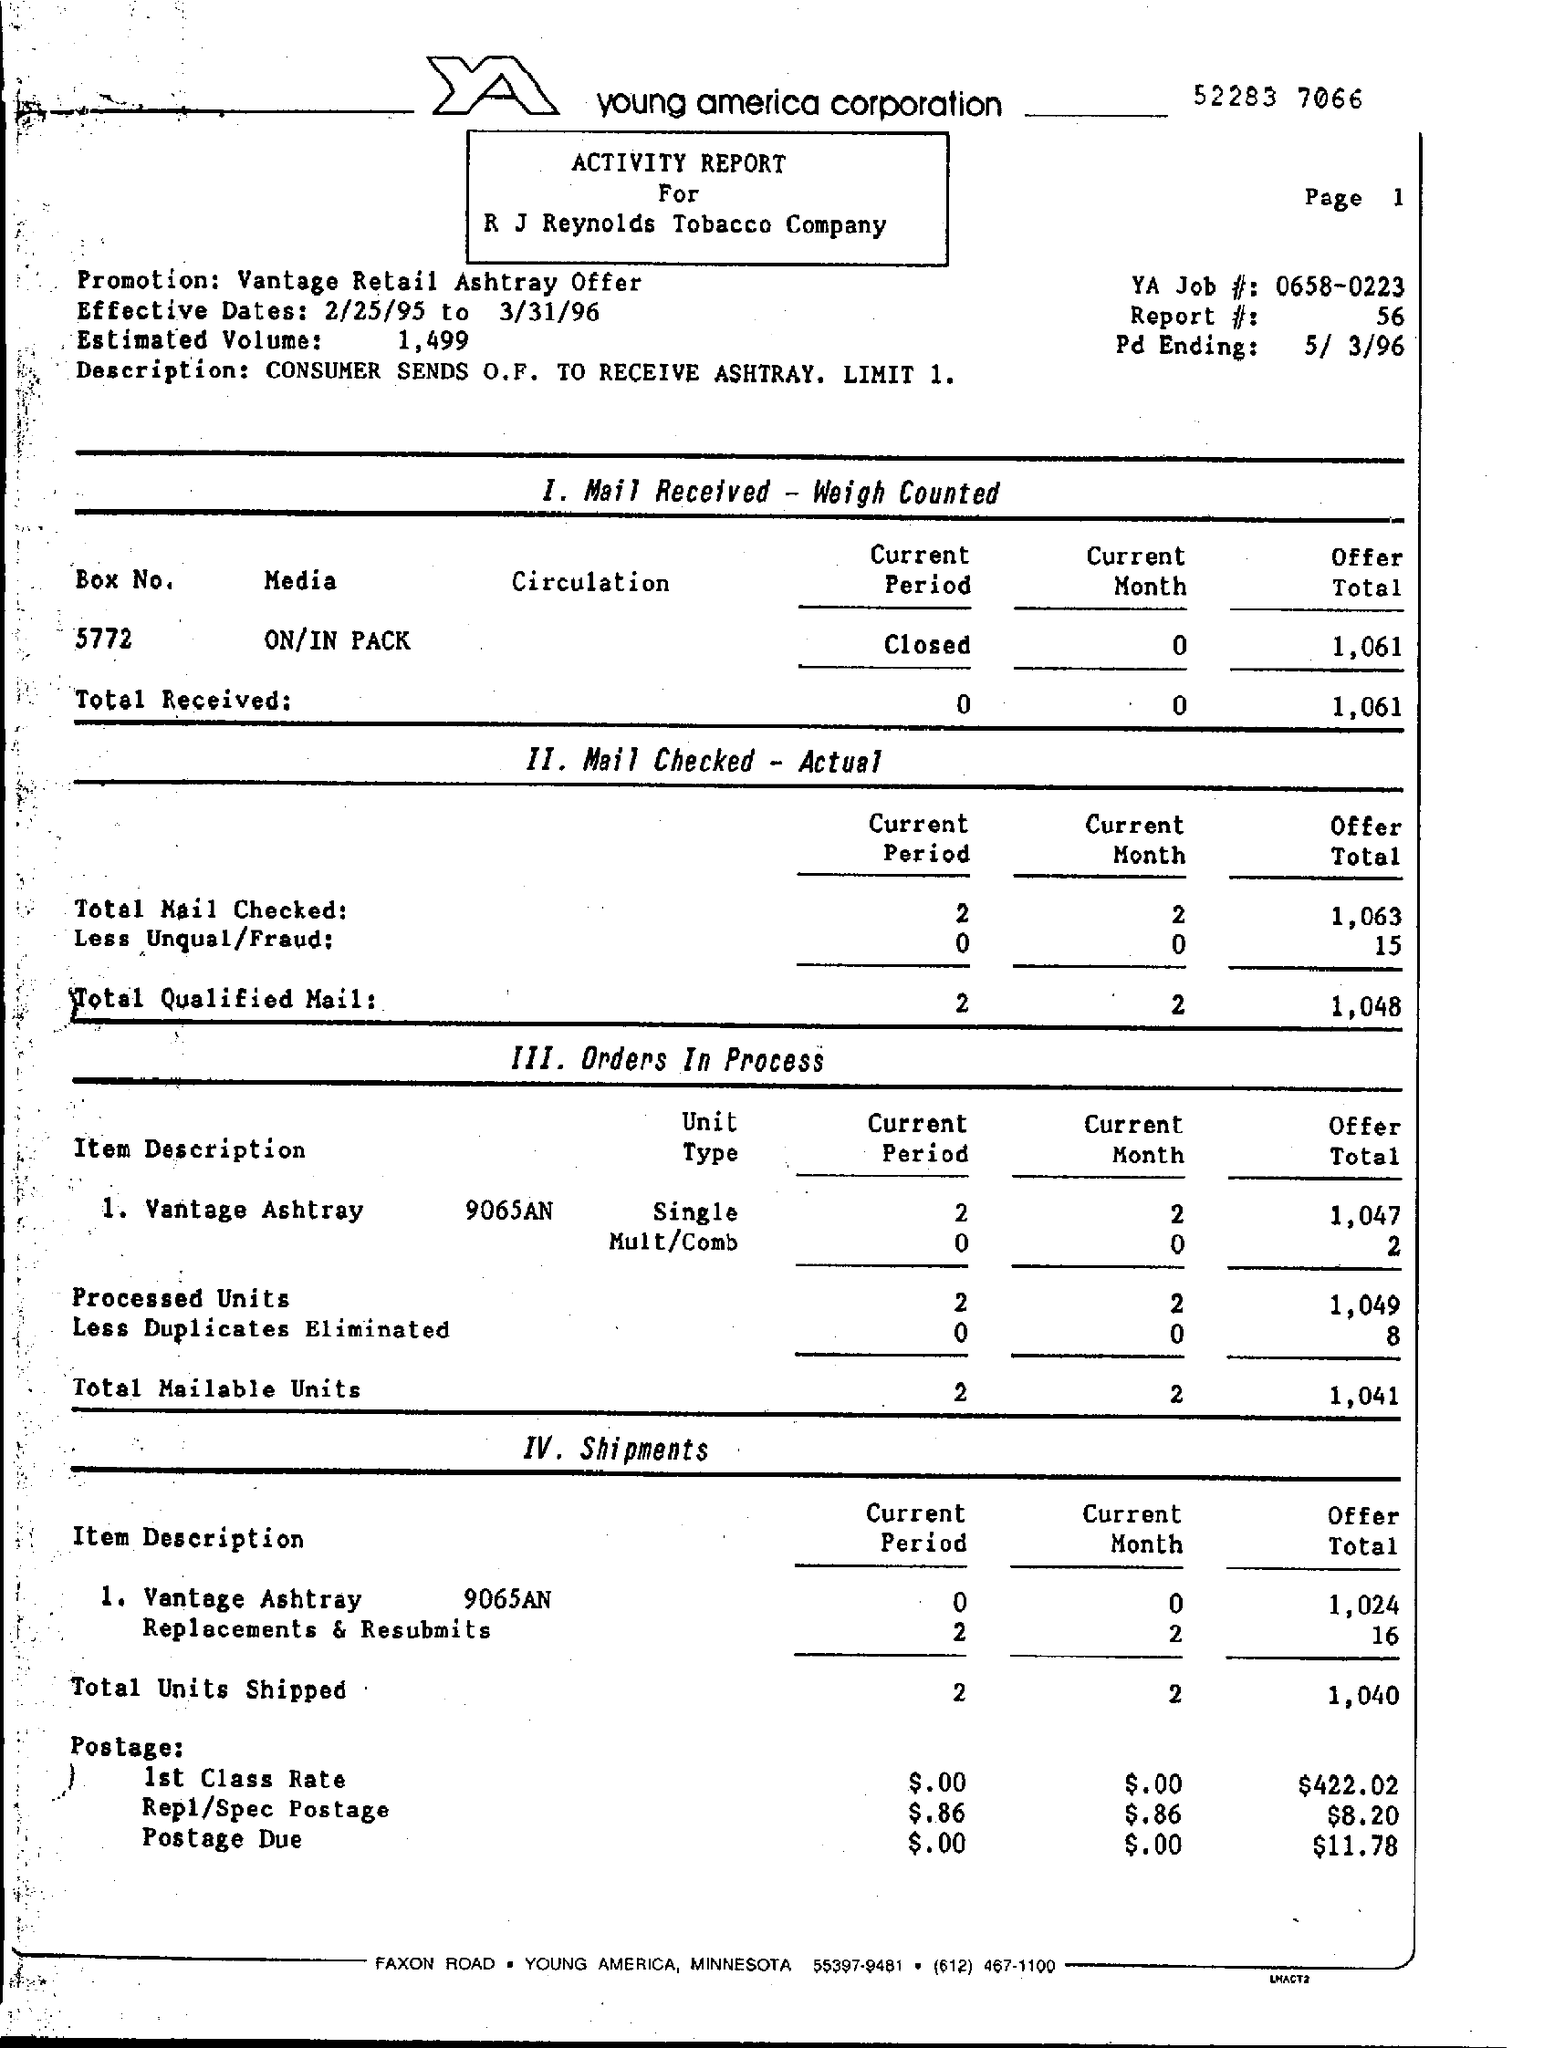Whats mentioned in the Description of ACTIVITY REPORT?
Ensure brevity in your answer.  CONSUMER SENDS O.F. TO RECEIVE ASHTRAY. LIMIT 1. What is the Estimated Volume?
Your answer should be compact. 1,499. What is the 1 stage?
Provide a short and direct response. Mail Received - Weigh Counted. How many Total Qualified Mail of Current Month were Checked-Actual?
Give a very brief answer. 2. How many Less Duplicates Eliminated in Offer Total in Ordes In Process?
Offer a terse response. 8. What is the Total Units Shipped in Current Period?
Give a very brief answer. 2. What is the offer Total in Postage Due?
Make the answer very short. $11.78. 